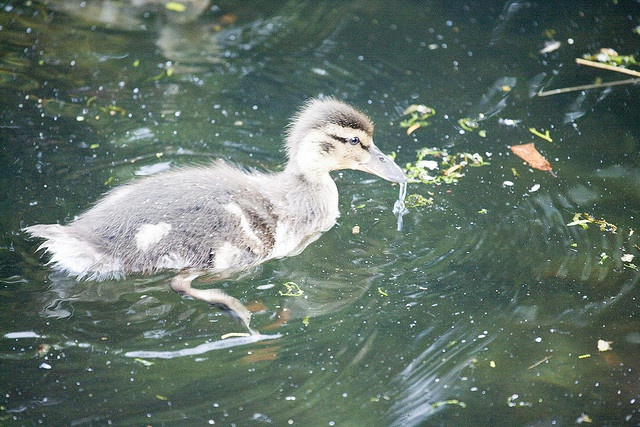Describe the objects in this image and their specific colors. I can see a bird in black, lightgray, darkgray, and gray tones in this image. 